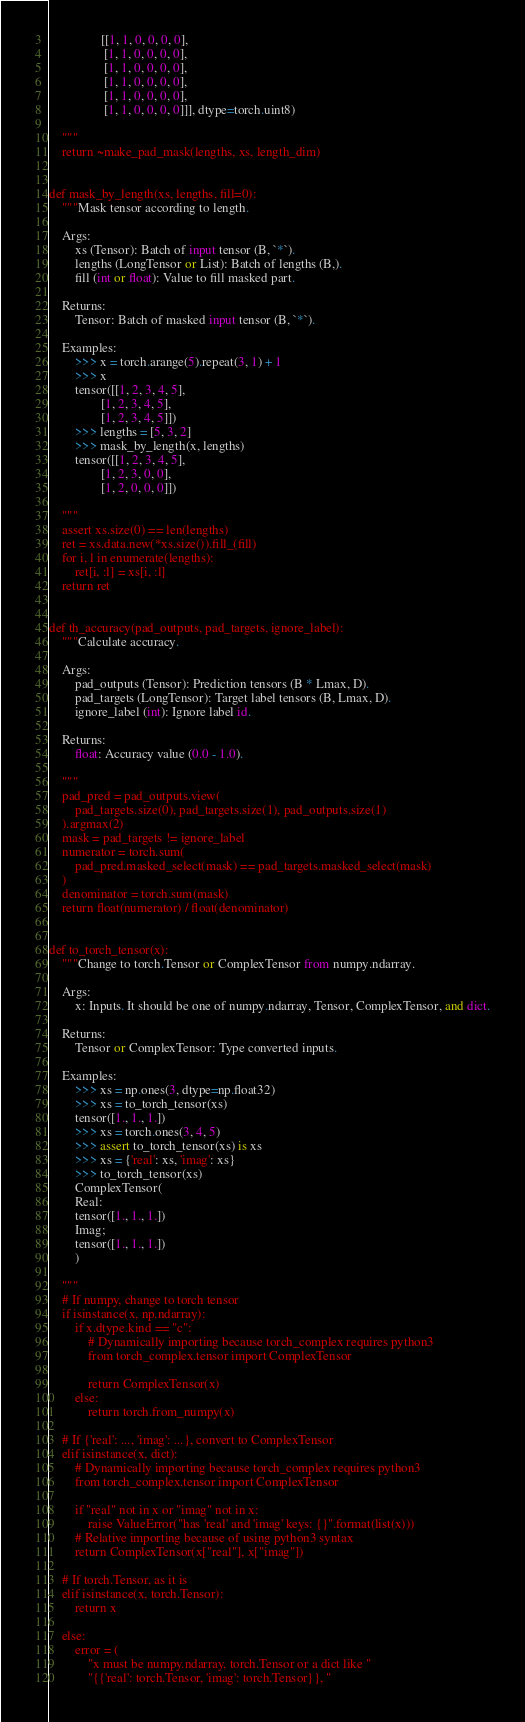<code> <loc_0><loc_0><loc_500><loc_500><_Python_>                [[1, 1, 0, 0, 0, 0],
                 [1, 1, 0, 0, 0, 0],
                 [1, 1, 0, 0, 0, 0],
                 [1, 1, 0, 0, 0, 0],
                 [1, 1, 0, 0, 0, 0],
                 [1, 1, 0, 0, 0, 0]]], dtype=torch.uint8)

    """
    return ~make_pad_mask(lengths, xs, length_dim)


def mask_by_length(xs, lengths, fill=0):
    """Mask tensor according to length.

    Args:
        xs (Tensor): Batch of input tensor (B, `*`).
        lengths (LongTensor or List): Batch of lengths (B,).
        fill (int or float): Value to fill masked part.

    Returns:
        Tensor: Batch of masked input tensor (B, `*`).

    Examples:
        >>> x = torch.arange(5).repeat(3, 1) + 1
        >>> x
        tensor([[1, 2, 3, 4, 5],
                [1, 2, 3, 4, 5],
                [1, 2, 3, 4, 5]])
        >>> lengths = [5, 3, 2]
        >>> mask_by_length(x, lengths)
        tensor([[1, 2, 3, 4, 5],
                [1, 2, 3, 0, 0],
                [1, 2, 0, 0, 0]])

    """
    assert xs.size(0) == len(lengths)
    ret = xs.data.new(*xs.size()).fill_(fill)
    for i, l in enumerate(lengths):
        ret[i, :l] = xs[i, :l]
    return ret


def th_accuracy(pad_outputs, pad_targets, ignore_label):
    """Calculate accuracy.

    Args:
        pad_outputs (Tensor): Prediction tensors (B * Lmax, D).
        pad_targets (LongTensor): Target label tensors (B, Lmax, D).
        ignore_label (int): Ignore label id.

    Returns:
        float: Accuracy value (0.0 - 1.0).

    """
    pad_pred = pad_outputs.view(
        pad_targets.size(0), pad_targets.size(1), pad_outputs.size(1)
    ).argmax(2)
    mask = pad_targets != ignore_label
    numerator = torch.sum(
        pad_pred.masked_select(mask) == pad_targets.masked_select(mask)
    )
    denominator = torch.sum(mask)
    return float(numerator) / float(denominator)


def to_torch_tensor(x):
    """Change to torch.Tensor or ComplexTensor from numpy.ndarray.

    Args:
        x: Inputs. It should be one of numpy.ndarray, Tensor, ComplexTensor, and dict.

    Returns:
        Tensor or ComplexTensor: Type converted inputs.

    Examples:
        >>> xs = np.ones(3, dtype=np.float32)
        >>> xs = to_torch_tensor(xs)
        tensor([1., 1., 1.])
        >>> xs = torch.ones(3, 4, 5)
        >>> assert to_torch_tensor(xs) is xs
        >>> xs = {'real': xs, 'imag': xs}
        >>> to_torch_tensor(xs)
        ComplexTensor(
        Real:
        tensor([1., 1., 1.])
        Imag;
        tensor([1., 1., 1.])
        )

    """
    # If numpy, change to torch tensor
    if isinstance(x, np.ndarray):
        if x.dtype.kind == "c":
            # Dynamically importing because torch_complex requires python3
            from torch_complex.tensor import ComplexTensor

            return ComplexTensor(x)
        else:
            return torch.from_numpy(x)

    # If {'real': ..., 'imag': ...}, convert to ComplexTensor
    elif isinstance(x, dict):
        # Dynamically importing because torch_complex requires python3
        from torch_complex.tensor import ComplexTensor

        if "real" not in x or "imag" not in x:
            raise ValueError("has 'real' and 'imag' keys: {}".format(list(x)))
        # Relative importing because of using python3 syntax
        return ComplexTensor(x["real"], x["imag"])

    # If torch.Tensor, as it is
    elif isinstance(x, torch.Tensor):
        return x

    else:
        error = (
            "x must be numpy.ndarray, torch.Tensor or a dict like "
            "{{'real': torch.Tensor, 'imag': torch.Tensor}}, "</code> 